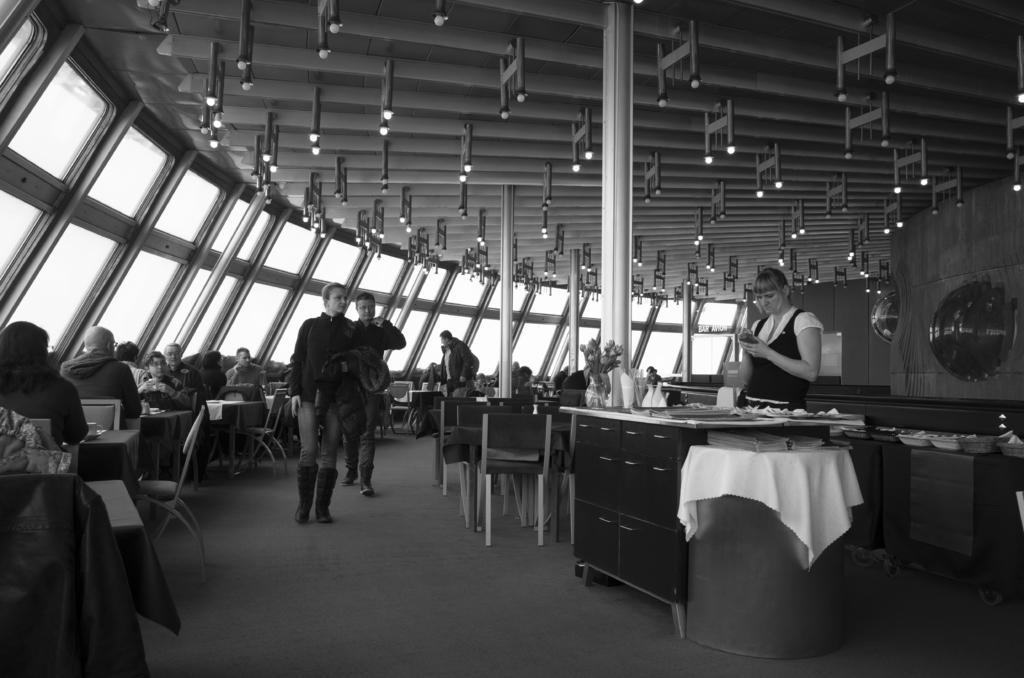In one or two sentences, can you explain what this image depicts? In the right Women is she wear a black and white dress at the top there are lights and in the middle a woman and a man are walking towards this side and these are the glass walls. 